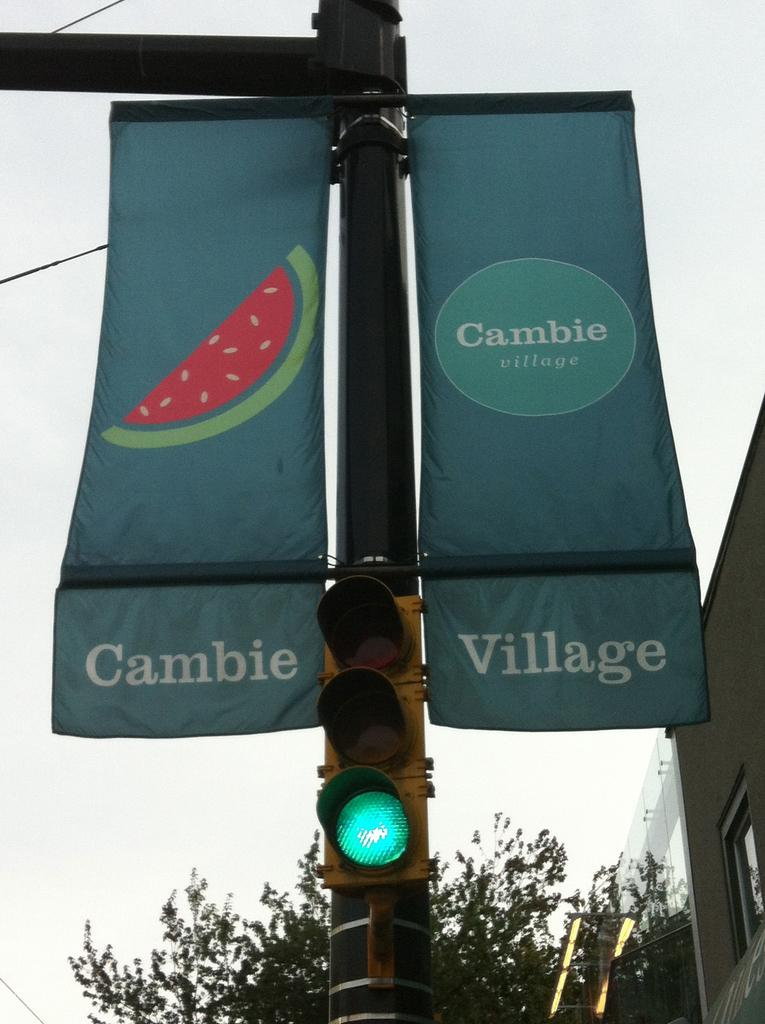Provide a one-sentence caption for the provided image. Two banners hanging vertically off a post with a green light that states Cambie Village. 